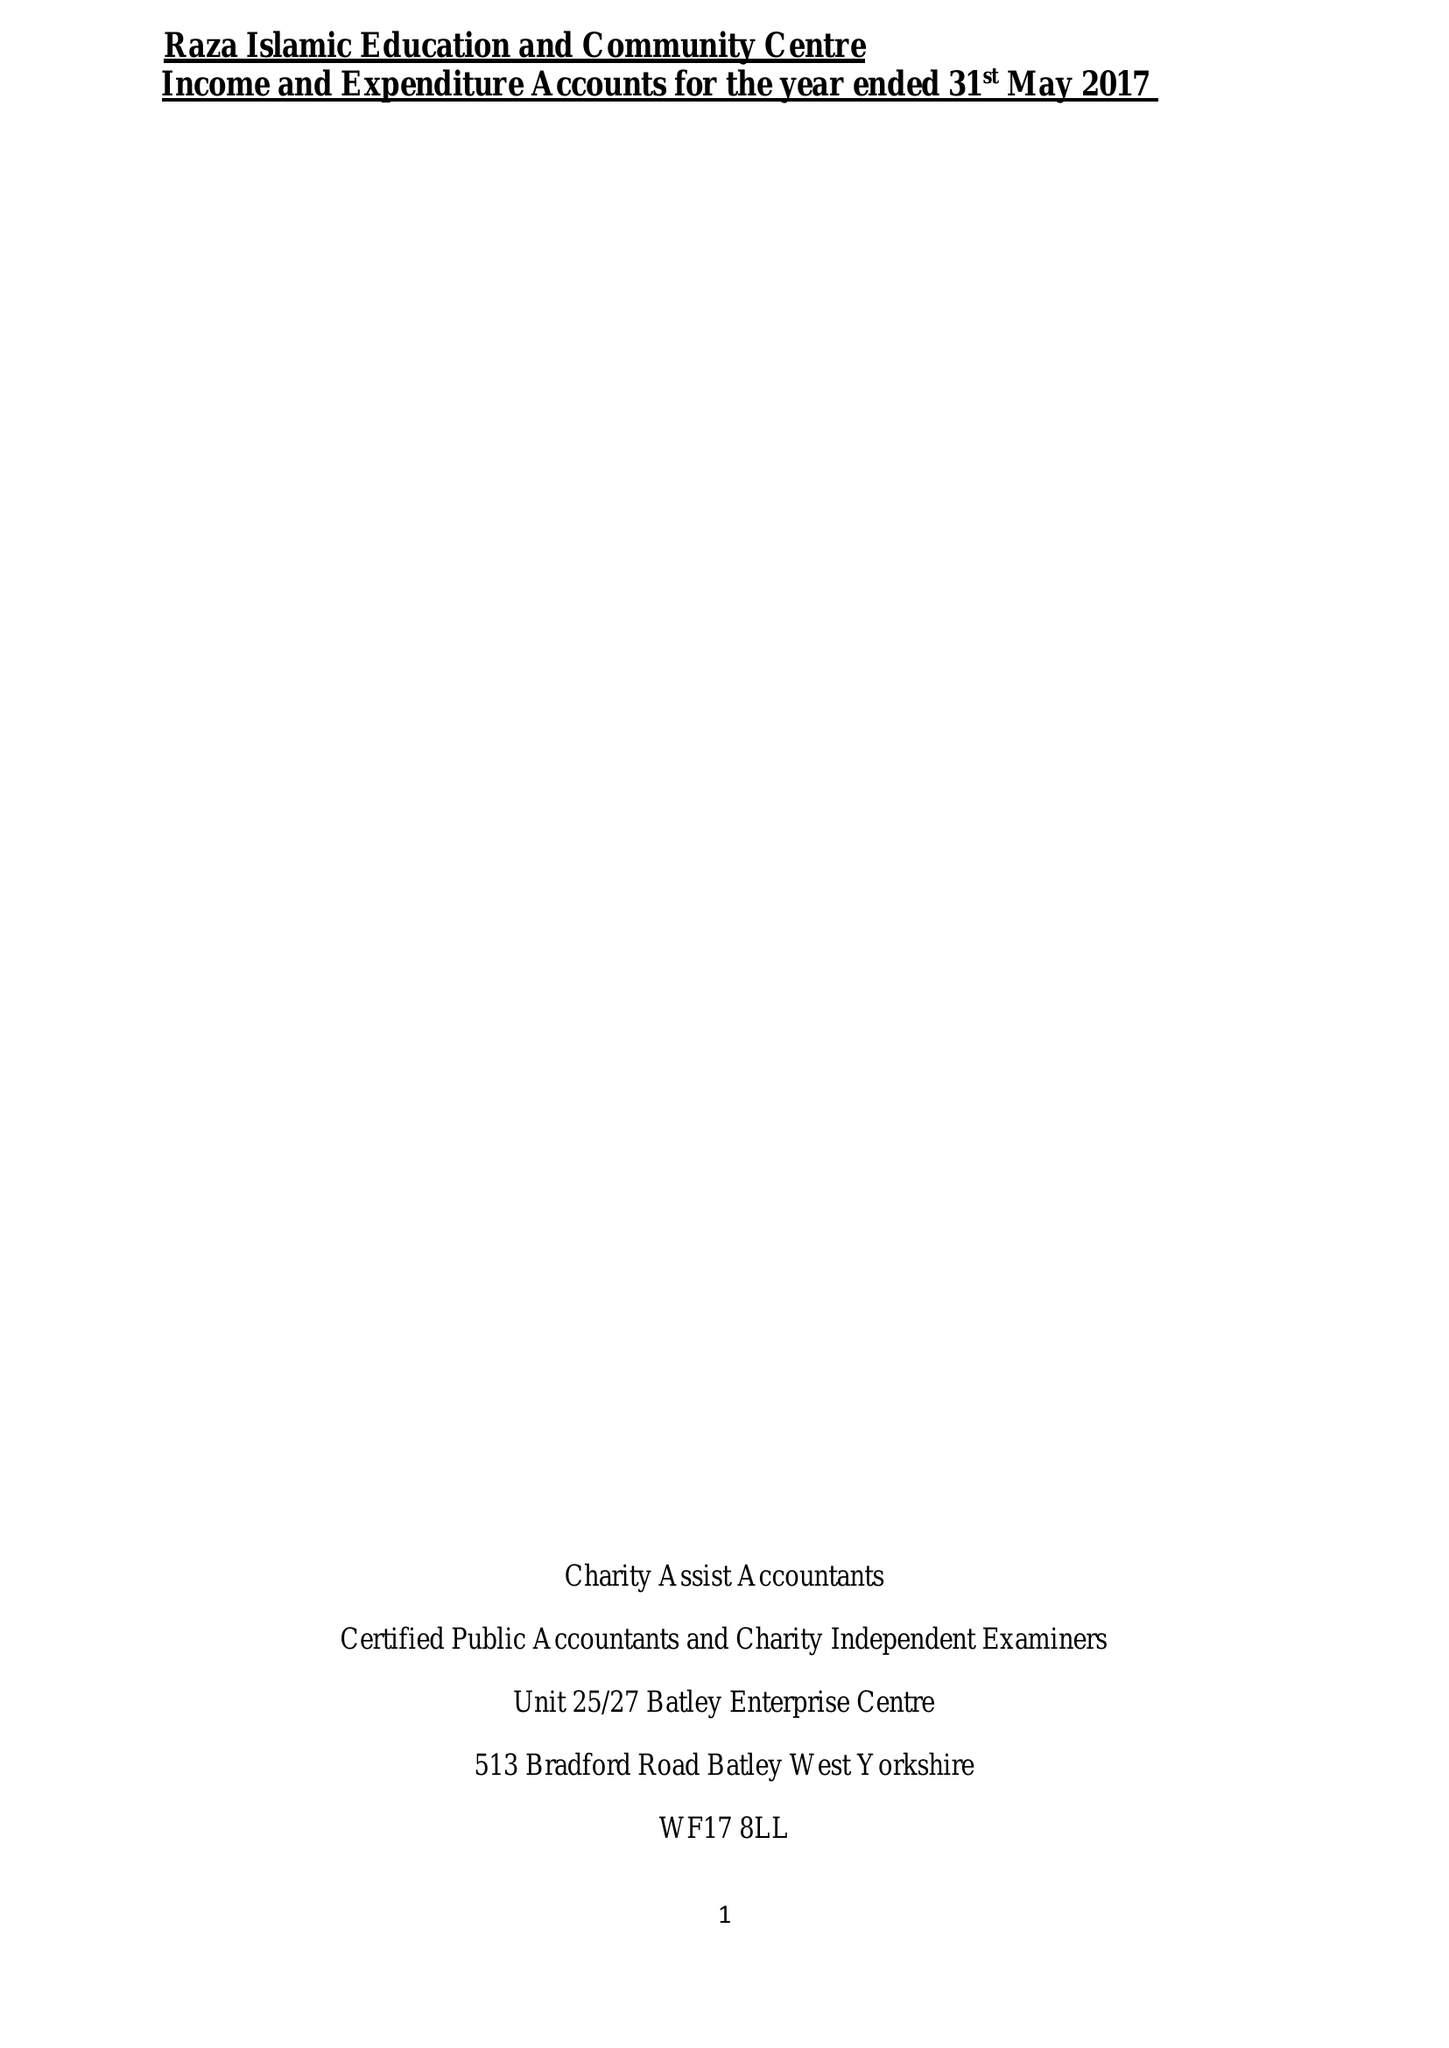What is the value for the address__postcode?
Answer the question using a single word or phrase. WF12 9HB 